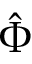Convert formula to latex. <formula><loc_0><loc_0><loc_500><loc_500>\hat { \Phi }</formula> 